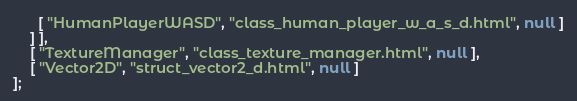Convert code to text. <code><loc_0><loc_0><loc_500><loc_500><_JavaScript_>      [ "HumanPlayerWASD", "class_human_player_w_a_s_d.html", null ]
    ] ],
    [ "TextureManager", "class_texture_manager.html", null ],
    [ "Vector2D", "struct_vector2_d.html", null ]
];</code> 